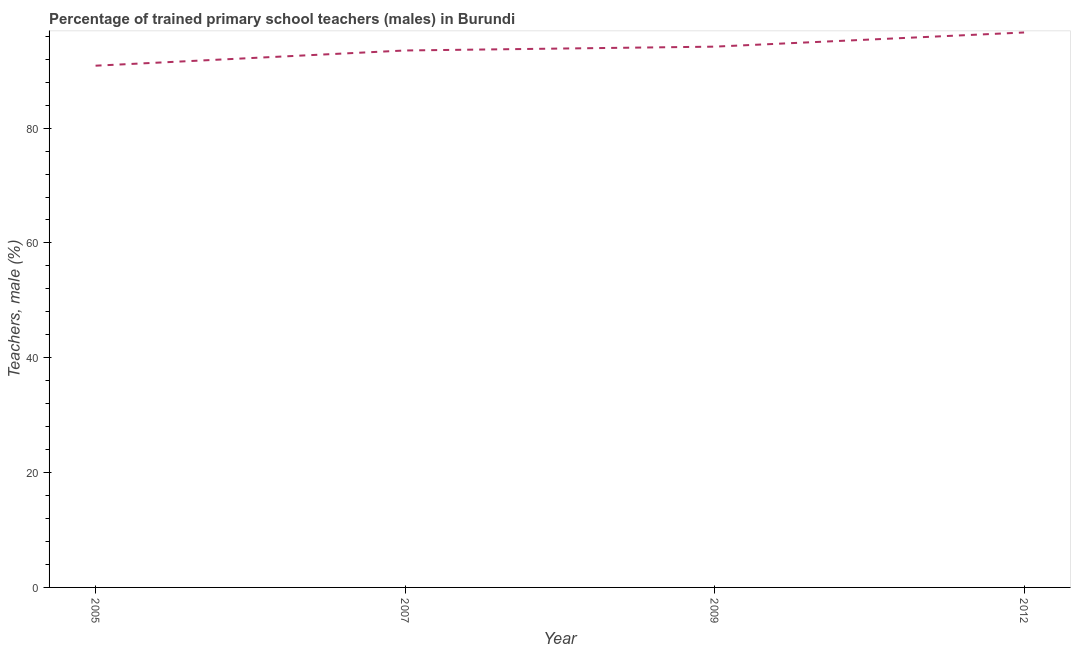What is the percentage of trained male teachers in 2012?
Give a very brief answer. 96.66. Across all years, what is the maximum percentage of trained male teachers?
Offer a very short reply. 96.66. Across all years, what is the minimum percentage of trained male teachers?
Offer a terse response. 90.88. In which year was the percentage of trained male teachers maximum?
Provide a succinct answer. 2012. In which year was the percentage of trained male teachers minimum?
Make the answer very short. 2005. What is the sum of the percentage of trained male teachers?
Provide a succinct answer. 375.26. What is the difference between the percentage of trained male teachers in 2007 and 2009?
Provide a short and direct response. -0.67. What is the average percentage of trained male teachers per year?
Keep it short and to the point. 93.81. What is the median percentage of trained male teachers?
Offer a very short reply. 93.86. Do a majority of the years between 2009 and 2005 (inclusive) have percentage of trained male teachers greater than 92 %?
Your answer should be very brief. No. What is the ratio of the percentage of trained male teachers in 2005 to that in 2009?
Offer a very short reply. 0.96. Is the percentage of trained male teachers in 2005 less than that in 2007?
Ensure brevity in your answer.  Yes. What is the difference between the highest and the second highest percentage of trained male teachers?
Provide a short and direct response. 2.47. What is the difference between the highest and the lowest percentage of trained male teachers?
Offer a very short reply. 5.78. In how many years, is the percentage of trained male teachers greater than the average percentage of trained male teachers taken over all years?
Offer a very short reply. 2. How many years are there in the graph?
Provide a succinct answer. 4. Are the values on the major ticks of Y-axis written in scientific E-notation?
Offer a terse response. No. What is the title of the graph?
Make the answer very short. Percentage of trained primary school teachers (males) in Burundi. What is the label or title of the X-axis?
Ensure brevity in your answer.  Year. What is the label or title of the Y-axis?
Provide a short and direct response. Teachers, male (%). What is the Teachers, male (%) in 2005?
Provide a short and direct response. 90.88. What is the Teachers, male (%) in 2007?
Give a very brief answer. 93.53. What is the Teachers, male (%) of 2009?
Make the answer very short. 94.19. What is the Teachers, male (%) of 2012?
Your answer should be compact. 96.66. What is the difference between the Teachers, male (%) in 2005 and 2007?
Ensure brevity in your answer.  -2.65. What is the difference between the Teachers, male (%) in 2005 and 2009?
Make the answer very short. -3.32. What is the difference between the Teachers, male (%) in 2005 and 2012?
Ensure brevity in your answer.  -5.78. What is the difference between the Teachers, male (%) in 2007 and 2009?
Your answer should be very brief. -0.67. What is the difference between the Teachers, male (%) in 2007 and 2012?
Offer a terse response. -3.13. What is the difference between the Teachers, male (%) in 2009 and 2012?
Your response must be concise. -2.47. What is the ratio of the Teachers, male (%) in 2005 to that in 2007?
Your answer should be compact. 0.97. What is the ratio of the Teachers, male (%) in 2005 to that in 2009?
Provide a succinct answer. 0.96. What is the ratio of the Teachers, male (%) in 2005 to that in 2012?
Your answer should be compact. 0.94. What is the ratio of the Teachers, male (%) in 2007 to that in 2009?
Keep it short and to the point. 0.99. What is the ratio of the Teachers, male (%) in 2009 to that in 2012?
Your answer should be very brief. 0.97. 